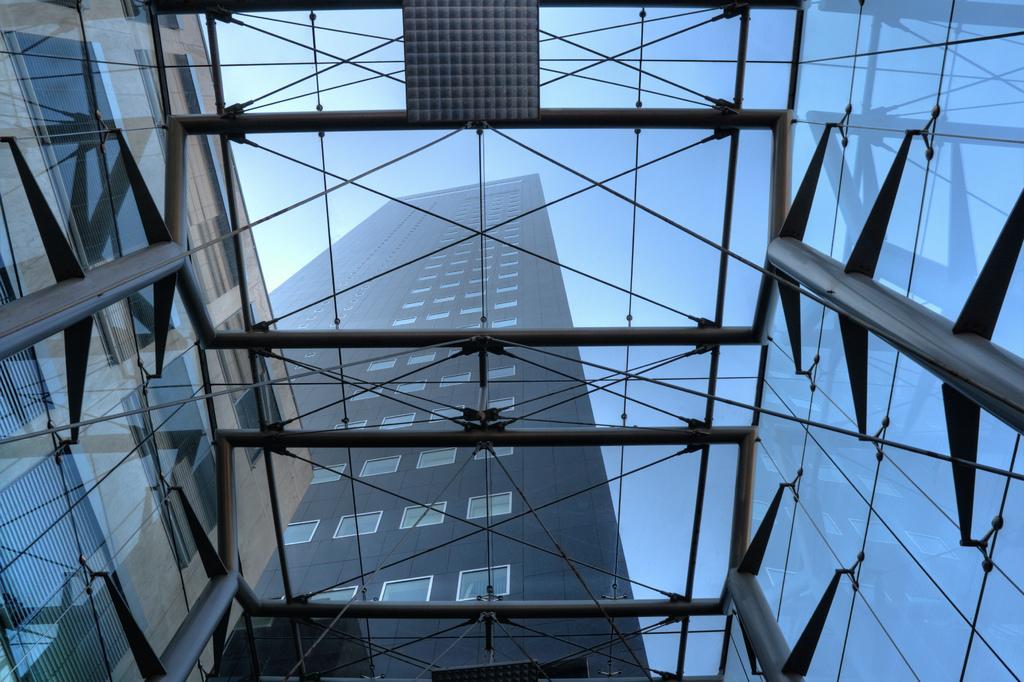Can you describe this image briefly? In this image, we can see buildings and at the top, there is a sky. 